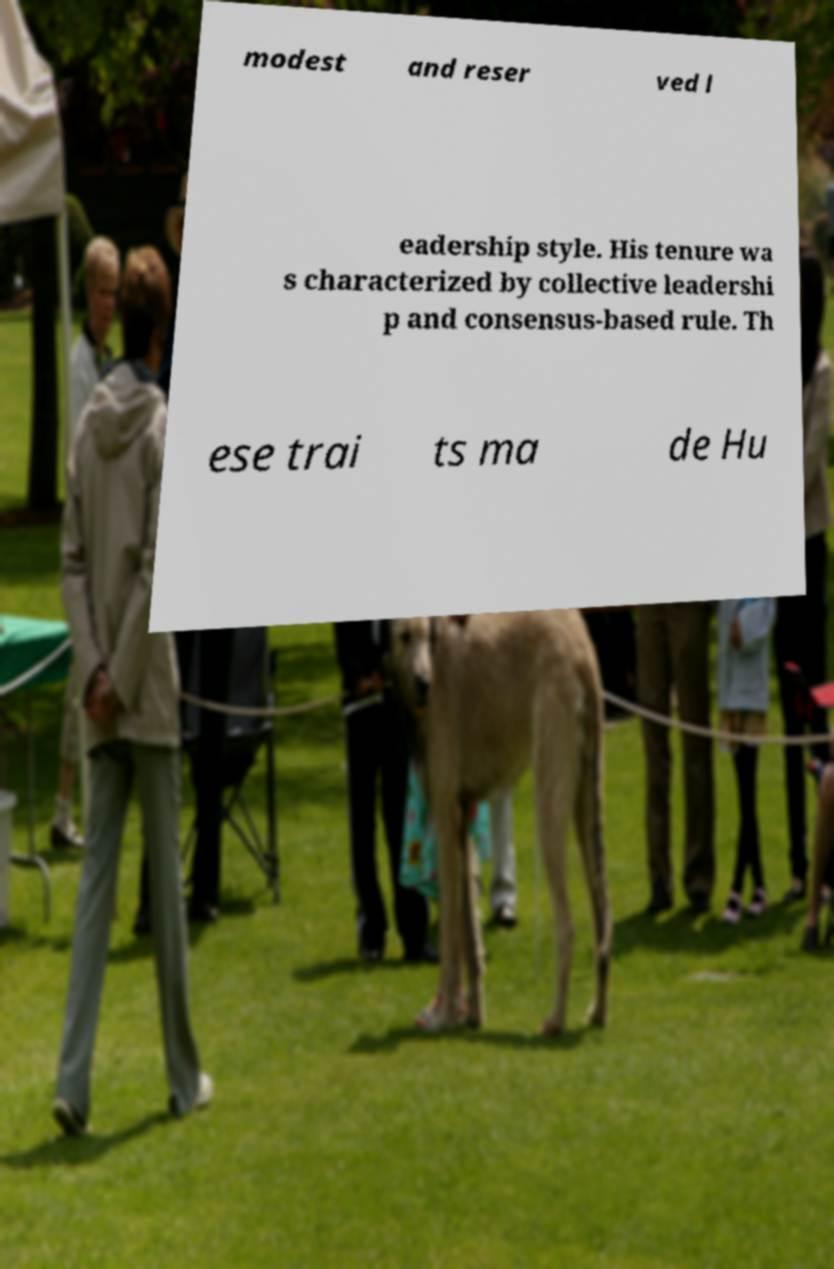There's text embedded in this image that I need extracted. Can you transcribe it verbatim? modest and reser ved l eadership style. His tenure wa s characterized by collective leadershi p and consensus-based rule. Th ese trai ts ma de Hu 